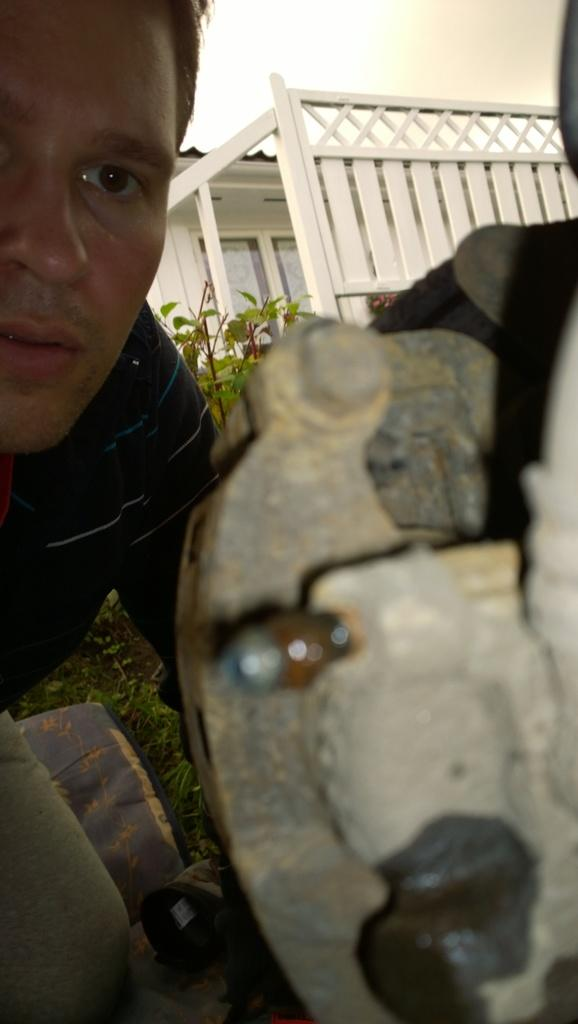Who is present in the image? There is a man in the image. What type of vegetation can be seen in the image? There is grass and leaves in the image. What architectural feature is visible in the image? There is a window and a fence in the image. What object can be seen in the image? There is an object in the image, but its specific nature is not mentioned in the facts. What is visible at the top of the image? The sky is visible at the top of the image. How many spiders are crawling on the man in the image? There are no spiders present in the image. What type of bean is being cooked in the image? There is no bean or cooking activity depicted in the image. 